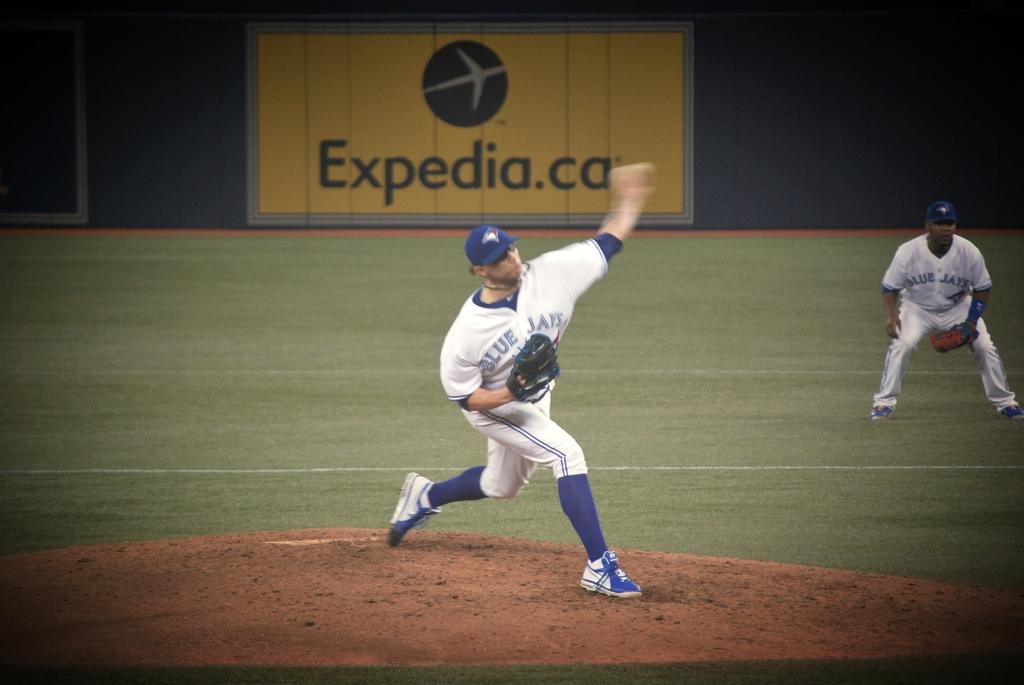Which travel website can be seen on the outfield wall?
Your response must be concise. Expedia.ca. 